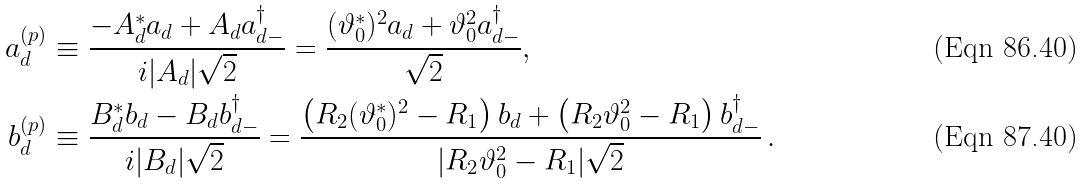<formula> <loc_0><loc_0><loc_500><loc_500>a _ { d } ^ { ( p ) } & \equiv \frac { - A _ { d } ^ { * } a _ { d } + A _ { d } a _ { d - } ^ { \dag } } { i | A _ { d } | \sqrt { 2 } } = \frac { ( \vartheta _ { 0 } ^ { * } ) ^ { 2 } a _ { d } + \vartheta _ { 0 } ^ { 2 } a _ { d - } ^ { \dag } } { \sqrt { 2 } } , \\ b _ { d } ^ { ( p ) } & \equiv \frac { B _ { d } ^ { * } b _ { d } - B _ { d } b _ { d - } ^ { \dag } } { i | B _ { d } | \sqrt { 2 } } = \frac { \left ( R _ { 2 } ( \vartheta _ { 0 } ^ { * } ) ^ { 2 } - R _ { 1 } \right ) b _ { d } + \left ( R _ { 2 } \vartheta _ { 0 } ^ { 2 } - R _ { 1 } \right ) b ^ { \dag } _ { d - } } { | R _ { 2 } \vartheta _ { 0 } ^ { 2 } - R _ { 1 } | \sqrt { 2 } } \, .</formula> 